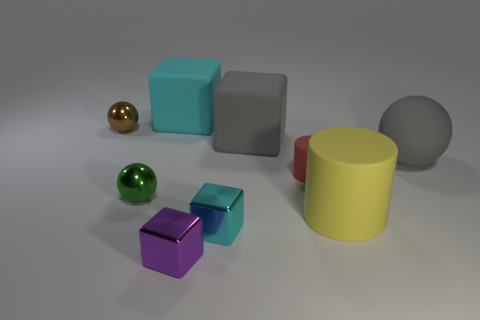Add 1 big matte spheres. How many objects exist? 10 Subtract all blocks. How many objects are left? 5 Add 5 metal blocks. How many metal blocks are left? 7 Add 2 small blue shiny objects. How many small blue shiny objects exist? 2 Subtract 0 green cubes. How many objects are left? 9 Subtract all large rubber things. Subtract all tiny gray shiny blocks. How many objects are left? 5 